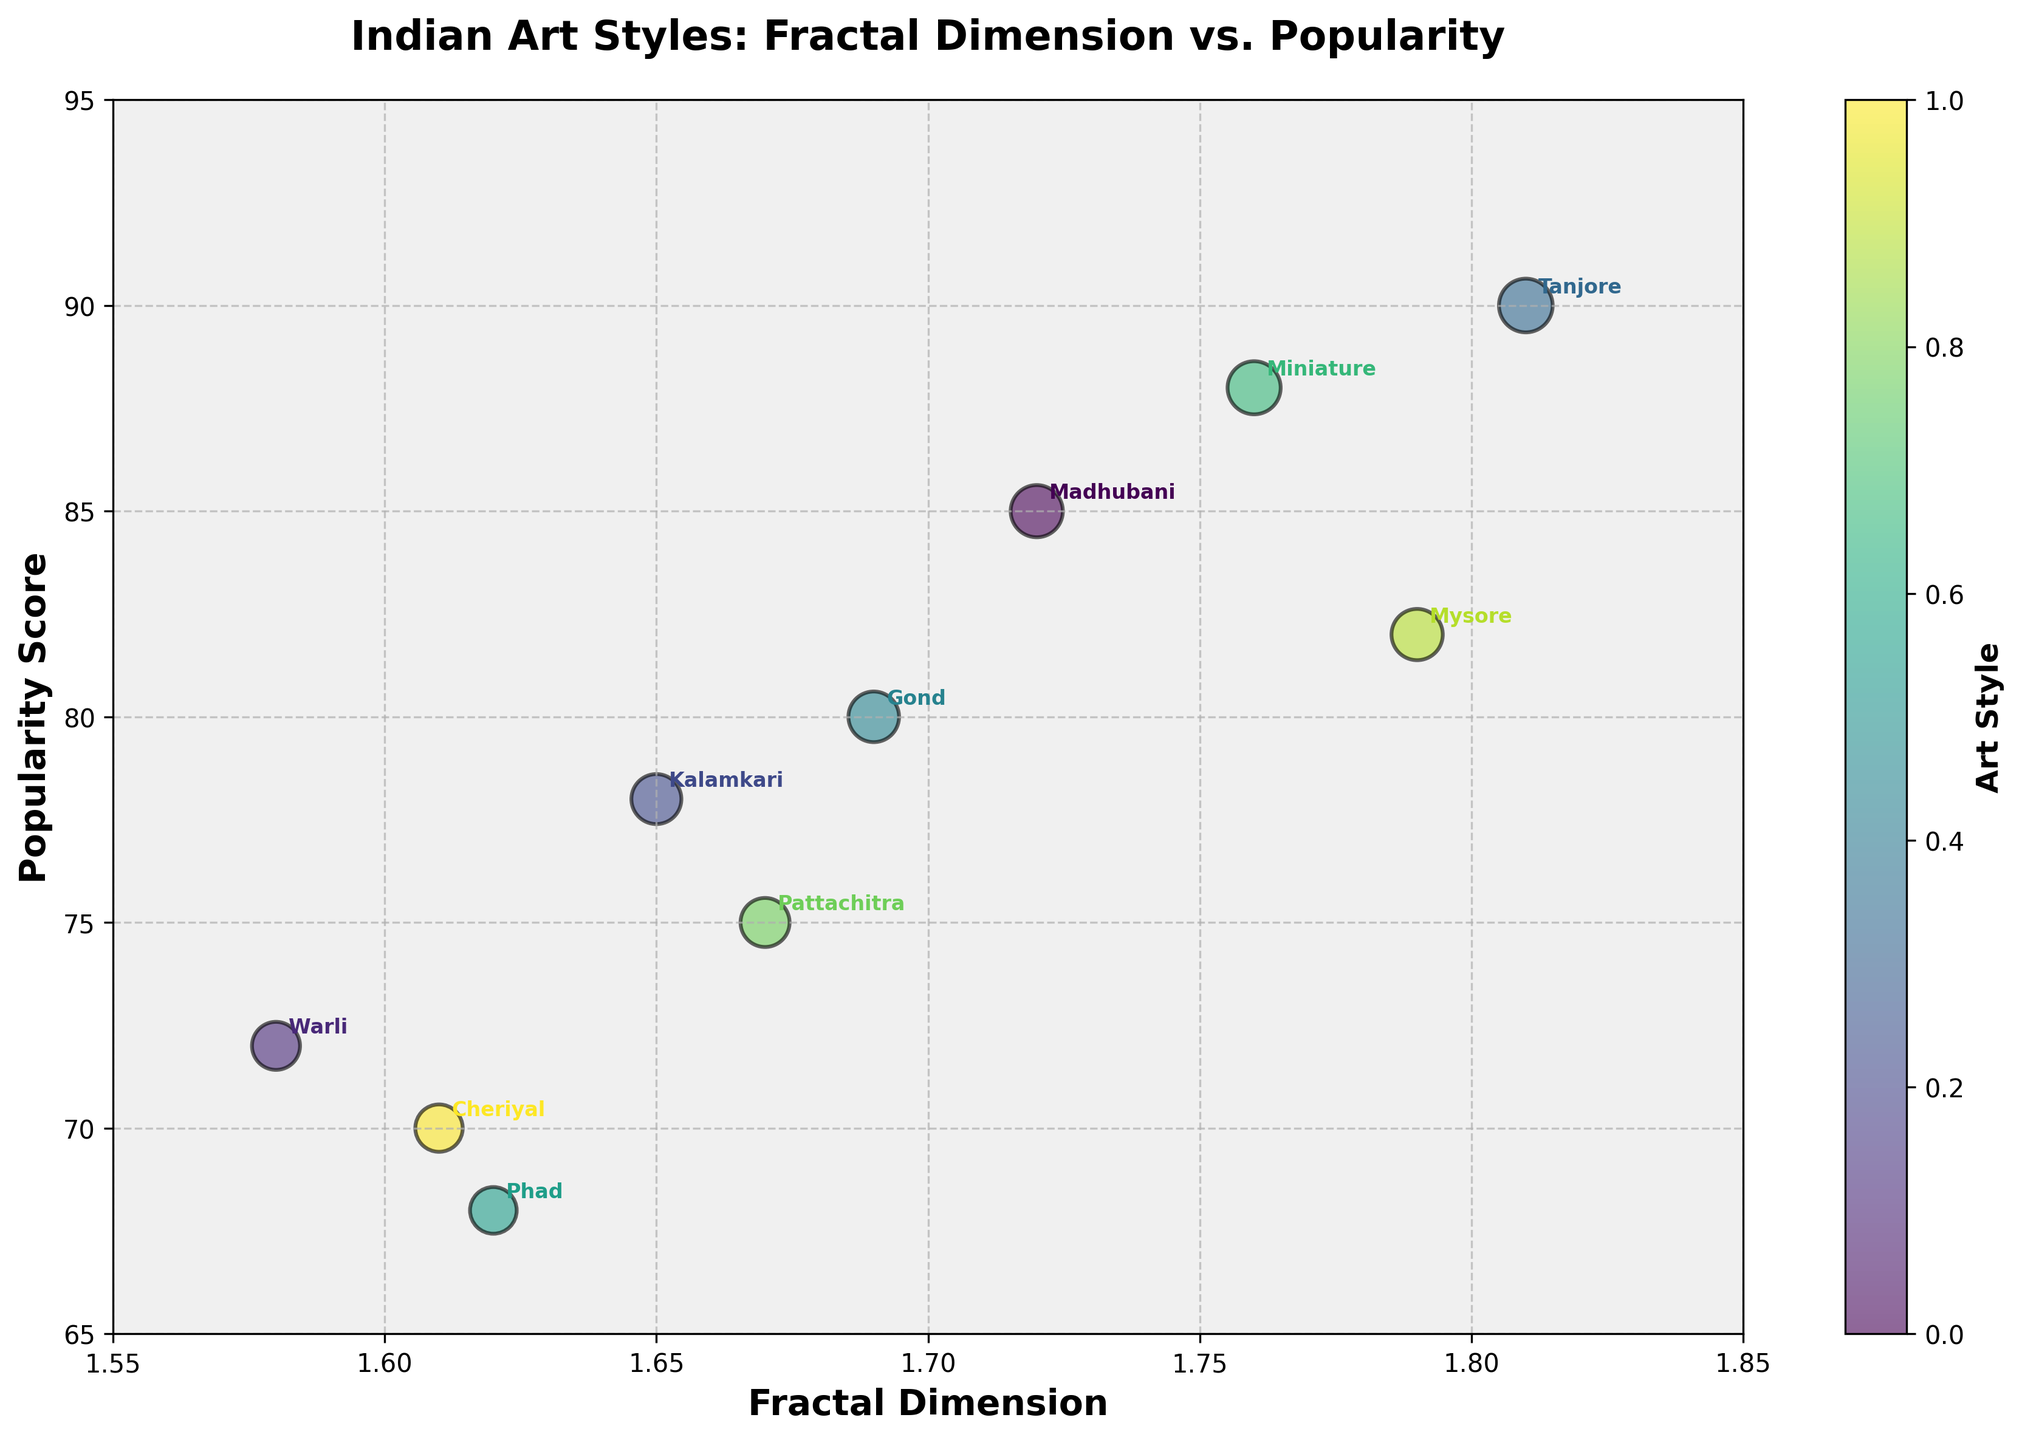What art style has the highest popularity score? Look for the bubble closest to the top of the y-axis. Madhubani has the highest popularity score of 90, located next to Tanjore which has a popularity score of 85.
Answer: Tanjore What is the fractal dimension range of the art styles displayed? Examine the x-axis limits of the plot. The x-axis starts at 1.55 and ends at 1.85.
Answer: 1.55 to 1.85 Which art style has the smallest popularity score? Look for the bubble closest to the bottom of the y-axis. Phad and Cheriyal have the smallest popularity scores of 68 and 70 respectively.
Answer: Phad How many art styles have a fractal dimension greater than 1.75? Identify the bubbles to the right of the 1.75 mark on the x-axis. Only Miniature and Mysore exceed this value.
Answer: 2 Which art style has the largest bubble size? Identify the largest bubble in the plot, which directly correlates with the highest popularity score. This corresponds to Tanjore with a popularity score of 90.
Answer: Tanjore Is there a noticeable trend between fractal dimension and popularity score? Visually inspect the chart for any pattern. Bubbles are spread rather uniformly, showing no clear positive or negative trend.
Answer: No noticeable trend Which two art styles are closest in both fractal dimensions and popularity score? Look for bubbles that are closely aligned horizontally and vertically. Madhubani and Miniature appear the closest, with fractal dimensions around 1.72 and 1.76 and popularity scores of 85 and 88, respectively.
Answer: Madhubani and Miniature What is the average popularity score of the displayed art styles? Add up all popularity scores and divide by the number of art styles: (85 + 72 + 78 + 90 + 80 + 68 + 88 + 75 + 82 + 70)/10 = 78.8
Answer: 78.8 Which art style has both a high fractal dimension and a high popularity score? Look at the top-right section of the chart. Tanjore with a fractal dimension of 1.81 and a popularity score of 90 fits this category.
Answer: Tanjore Are any art styles with low fractal dimensions notably popular? Focus on the left side of the plot and high points on the y-axis. Warli has a relatively low fractal dimension (1.58) and a popularity score of 72, which is above average but not notably high.
Answer: No 